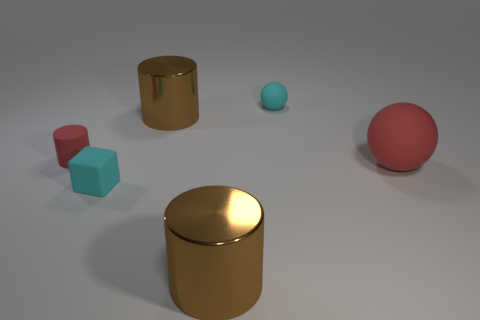Subtract all brown blocks. How many brown cylinders are left? 2 Subtract all tiny red rubber cylinders. How many cylinders are left? 2 Add 3 tiny balls. How many objects exist? 9 Subtract all spheres. How many objects are left? 4 Add 5 red matte cylinders. How many red matte cylinders exist? 6 Subtract 0 purple balls. How many objects are left? 6 Subtract all big red matte objects. Subtract all shiny cylinders. How many objects are left? 3 Add 2 spheres. How many spheres are left? 4 